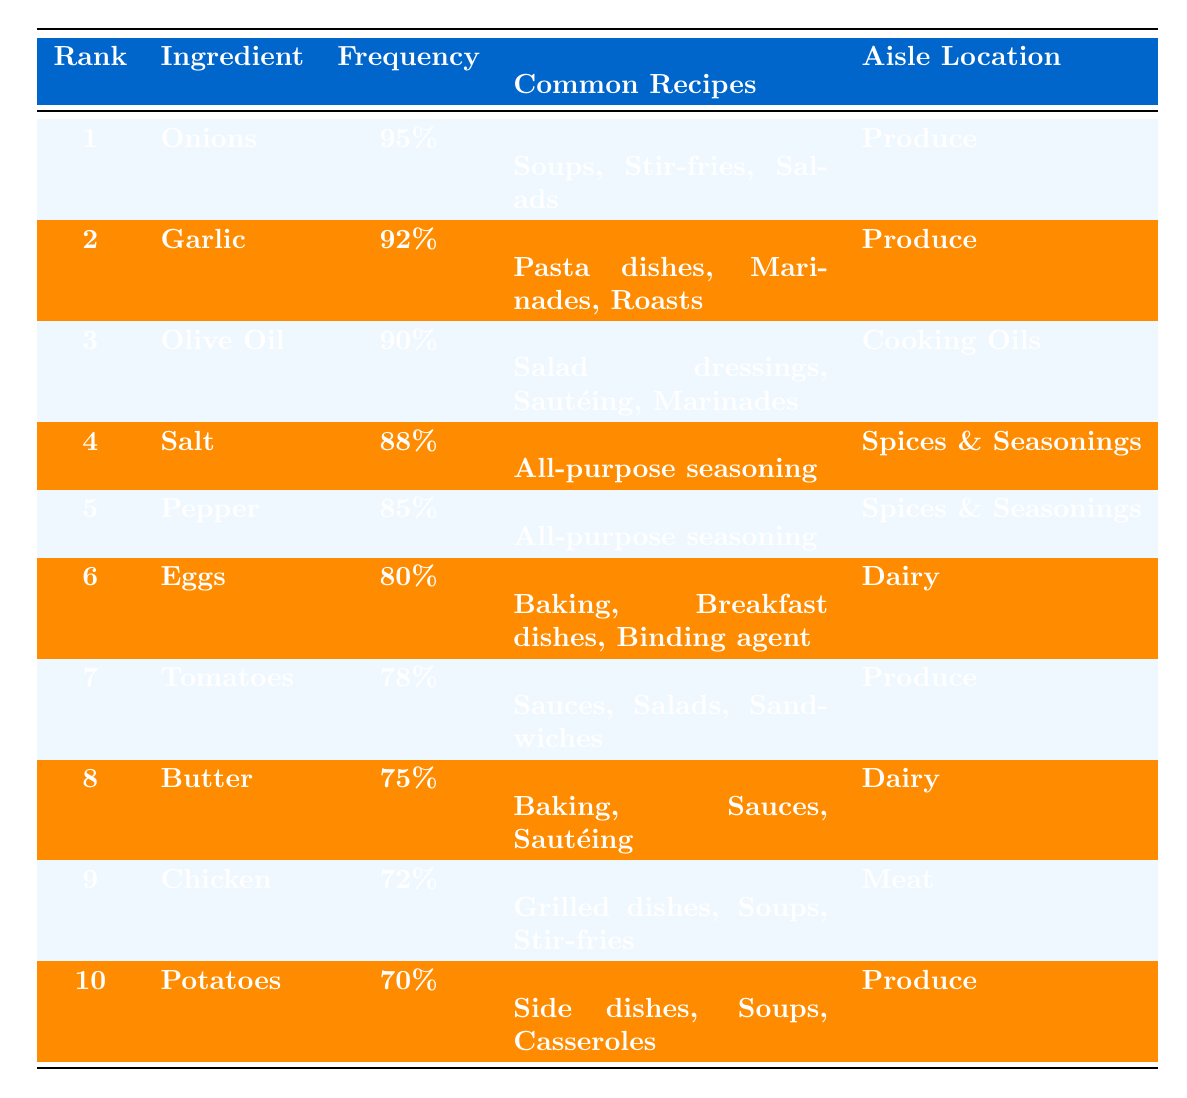What ingredient has the highest frequency of request? The highest frequency of request is identified in the Frequency column. Looking through the table, "Onions" has the highest frequency at 95%.
Answer: Onions How many ingredients have a frequency of over 80%? We can filter the ingredients with frequencies shown in the table. The ingredients with over 80% frequency are: Onions (95%), Garlic (92%), Olive Oil (90%), Salt (88%), Pepper (85%), and Eggs (80%). Counting these gives us a total of six ingredients.
Answer: Six Which aisle contains the ingredient with the second highest frequency? First, identify the ingredient with the second highest frequency, which is "Garlic" at 92%. Now look at the Aisle Location for Garlic, which is "Produce." Thus, the aisle containing this ingredient is the Produce aisle.
Answer: Produce Is Butter a commonly requested ingredient for baking? Butter appears in the Common Recipes column where it is listed as used in Baking, Sauces, and Sautéing. Therefore, it is valid to say that Butter is indeed a commonly requested ingredient for baking.
Answer: Yes What is the frequency difference between the ingredient ranked third and the one ranked fifth? The ingredient ranked third is "Olive Oil," with a frequency of 90%. The ingredient ranked fifth is "Pepper," with a frequency of 85%. The frequency difference is calculated as 90% - 85% = 5%.
Answer: 5% 